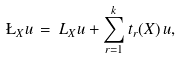Convert formula to latex. <formula><loc_0><loc_0><loc_500><loc_500>\L _ { X } u \, = \, L _ { X } u + \sum _ { r = 1 } ^ { k } t _ { r } ( X ) \, u ,</formula> 